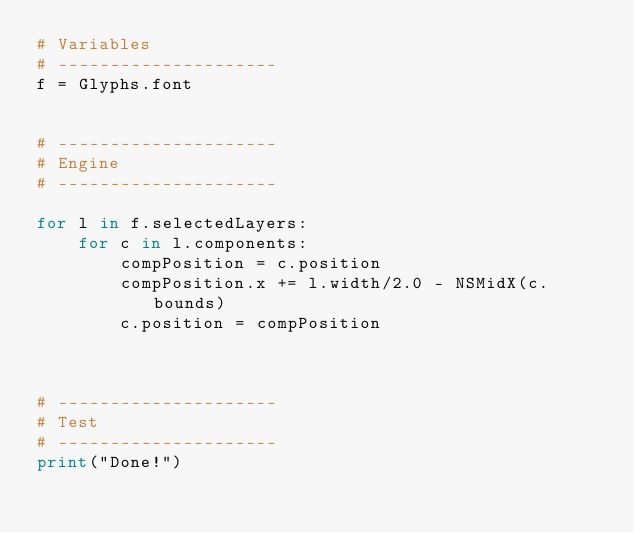Convert code to text. <code><loc_0><loc_0><loc_500><loc_500><_Python_># Variables
# ---------------------
f = Glyphs.font


# ---------------------
# Engine
# ---------------------

for l in f.selectedLayers:
	for c in l.components:
		compPosition = c.position
		compPosition.x += l.width/2.0 - NSMidX(c.bounds)
		c.position = compPosition

		

# ---------------------
# Test
# ---------------------
print("Done!")

</code> 